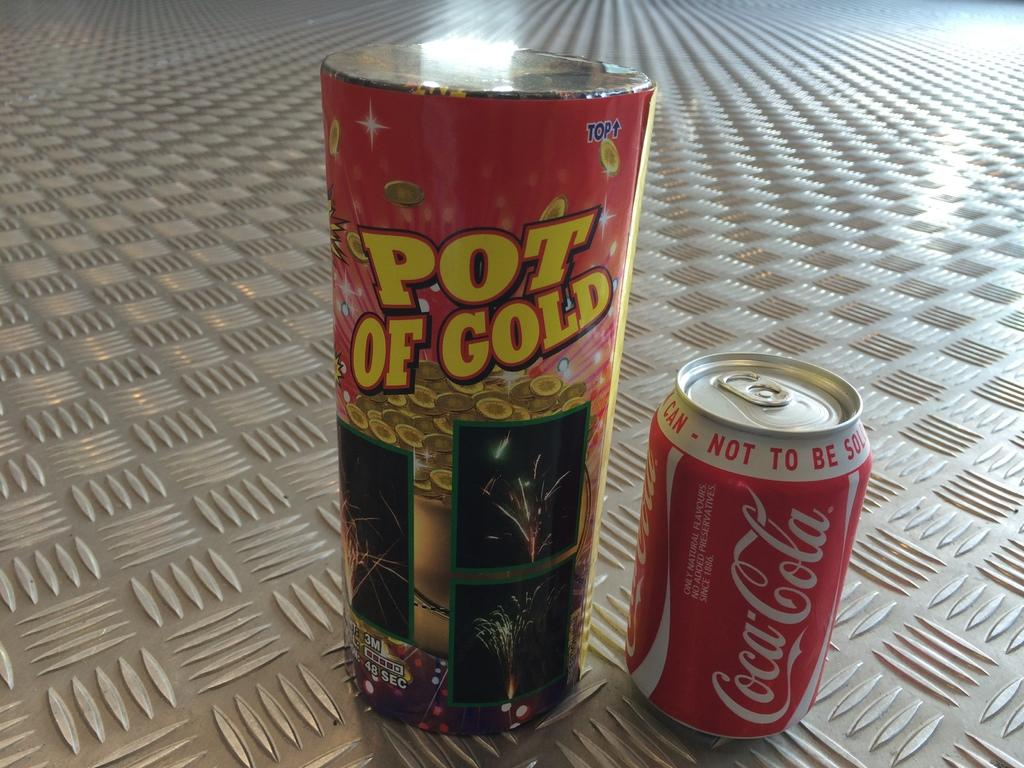Provide a one-sentence caption for the provided image. A container of Pot of Gold beside a can of Coca-Cola. 